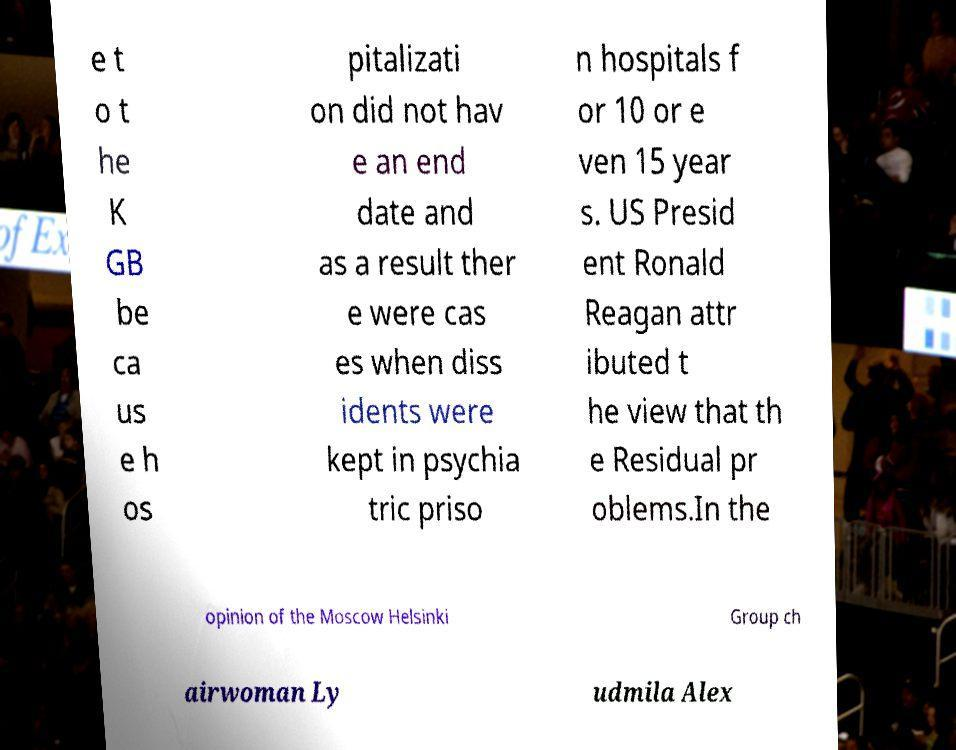Please read and relay the text visible in this image. What does it say? e t o t he K GB be ca us e h os pitalizati on did not hav e an end date and as a result ther e were cas es when diss idents were kept in psychia tric priso n hospitals f or 10 or e ven 15 year s. US Presid ent Ronald Reagan attr ibuted t he view that th e Residual pr oblems.In the opinion of the Moscow Helsinki Group ch airwoman Ly udmila Alex 